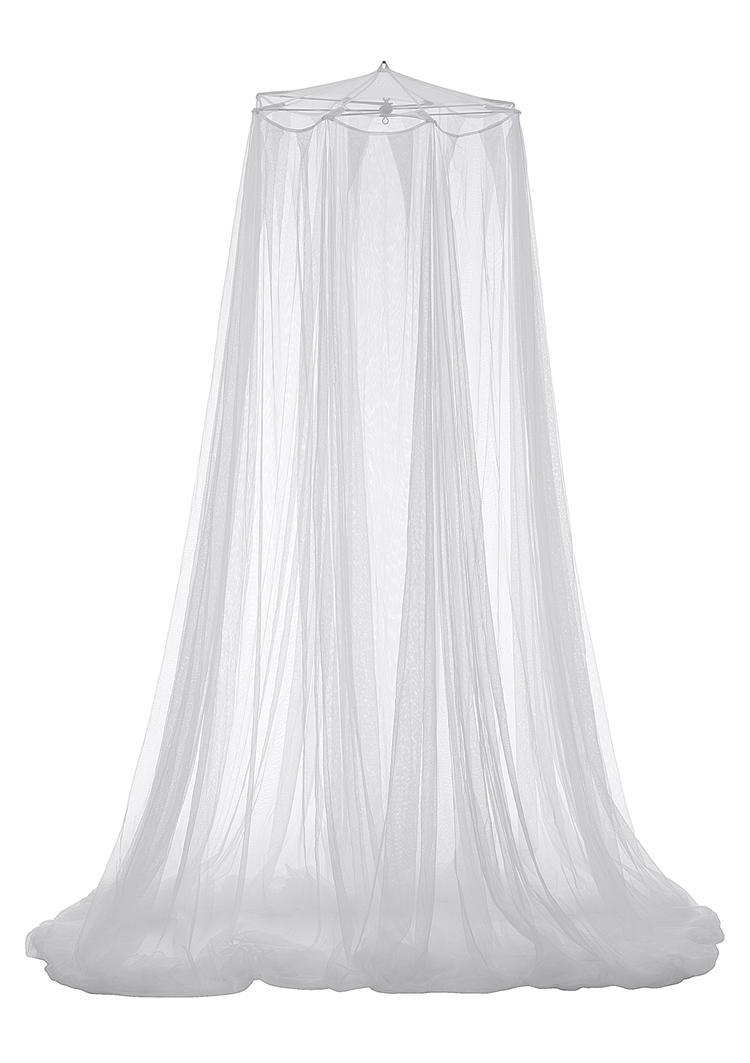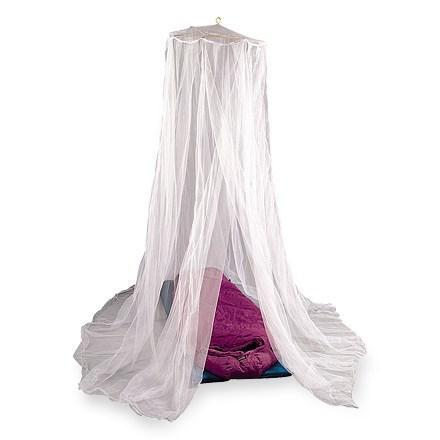The first image is the image on the left, the second image is the image on the right. Evaluate the accuracy of this statement regarding the images: "None of these bed canopies are presently covering a regular, rectangular bed.". Is it true? Answer yes or no. Yes. The first image is the image on the left, the second image is the image on the right. Examine the images to the left and right. Is the description "Exactly one net is white." accurate? Answer yes or no. No. 